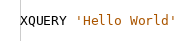Convert code to text. <code><loc_0><loc_0><loc_500><loc_500><_SQL_>XQUERY 'Hello World'</code> 